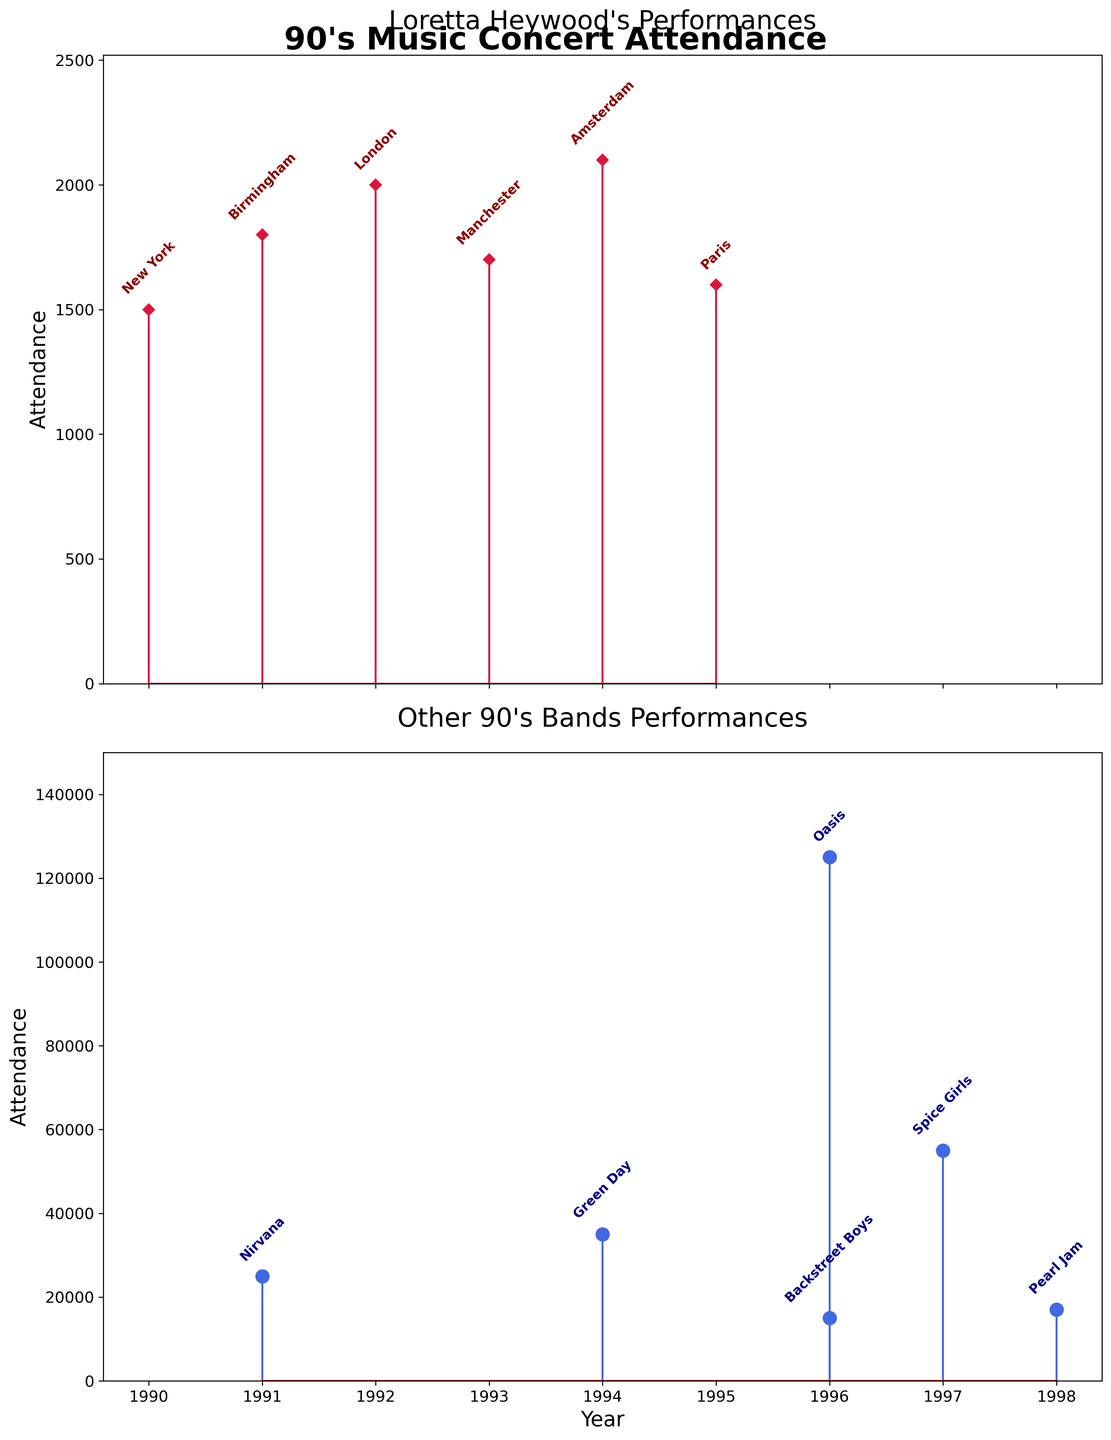What is the title of the figure? The figure has two plots, each with its own title. The main title of the figure can be found at the top, which reads "90's Music Concert Attendance"
Answer: 90's Music Concert Attendance What is the range of attendance values for Loretta Heywood's performances? By looking at the first subplot for Loretta Heywood's performances, you can see the highest attendance is 2100 and the lowest is 1500. So the range is 2100 - 1500.
Answer: 600 Which year had the highest concert attendance for Loretta Heywood? In the first subplot, look for the stem with the highest point. The highest attendance for Loretta Heywood is in 1994, with 2100 attendees.
Answer: 1994 How many data points (concert performances) are shown for Loretta Heywood? Counting the stems in the first subplot of Loretta Heywood's performances, you find there are six data points.
Answer: 6 Which band had the highest attendance among the other 90's bands, and what was the attendance? In the second subplot, the highest attendance is indicated by the tallest stem. The band with the highest attendance is Oasis with 125000 attendees in 1996.
Answer: Oasis, 125000 Compare the highest attendance for Loretta Heywood with the average attendance of the other 90's bands. First, find the highest attendance for Loretta Heywood, which is 2100. Then, calculate the average attendance for the other bands: (25000 + 15000 + 55000 + 17000 + 125000 + 35000) / 6 = 41500. Comparing 2100 with 41500 shows that Loretta's highest attendance is much lower.
Answer: Loretta Heywood: 2100, Other 90's Bands Average: 41500 Which city hosted the highest-attended Loretta Heywood concert? In the first subplot, the highest attendance for Loretta Heywood is in 1994 with 2100 attendees. The annotation above the stem for 1994 labels the city as Amsterdam.
Answer: Amsterdam What is the difference in attendance between the largest and smallest concerts for Loretta Heywood? The largest concert for Loretta Heywood had 2100 attendees and the smallest had 1500. The difference is 2100 - 1500 = 600.
Answer: 600 How many concerts for other bands had an attendance greater than the highest attendance for Loretta Heywood? The highest attendance for Loretta Heywood is 2100. In the subplot for other 90's bands, count how many stems are taller than this value, which are all six concerts: Nirvana (25000), Backstreet Boys (15000), Spice Girls (55000), Pearl Jam (17000), Oasis (125000), and Green Day (35000).
Answer: 6 